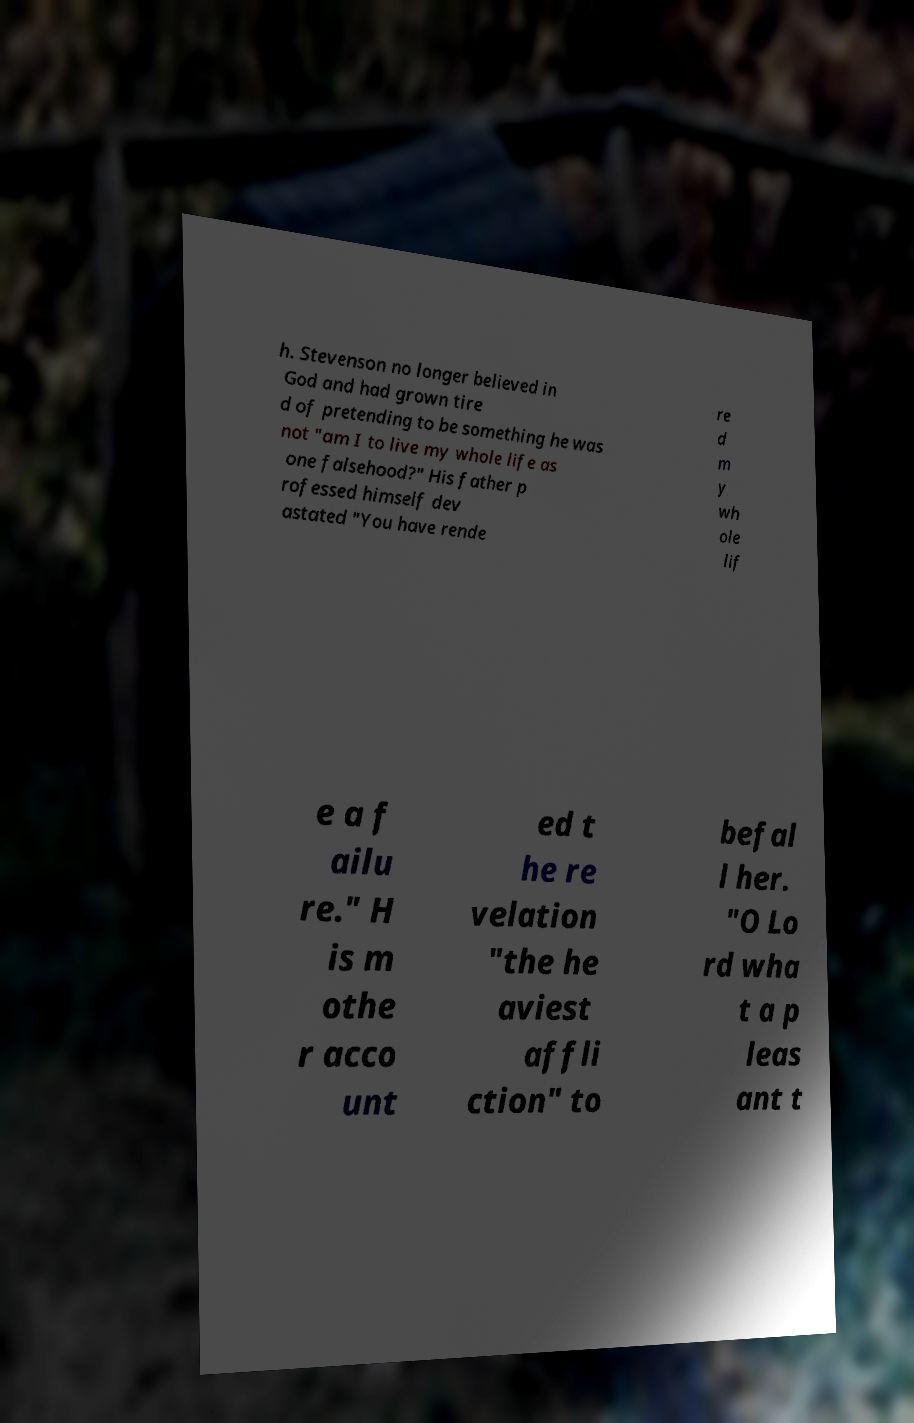Can you read and provide the text displayed in the image?This photo seems to have some interesting text. Can you extract and type it out for me? h. Stevenson no longer believed in God and had grown tire d of pretending to be something he was not "am I to live my whole life as one falsehood?" His father p rofessed himself dev astated "You have rende re d m y wh ole lif e a f ailu re." H is m othe r acco unt ed t he re velation "the he aviest affli ction" to befal l her. "O Lo rd wha t a p leas ant t 